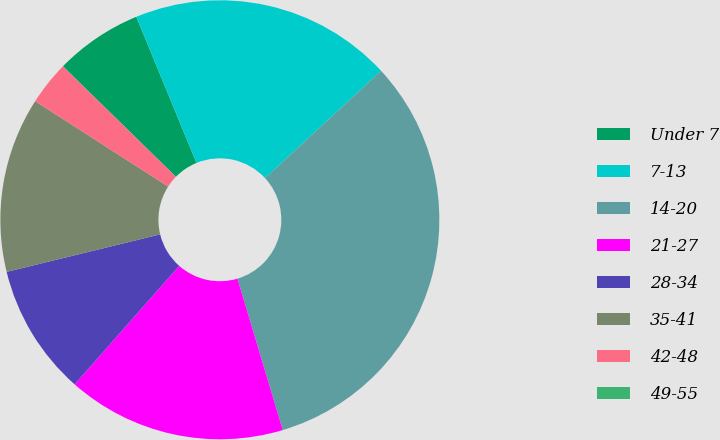Convert chart to OTSL. <chart><loc_0><loc_0><loc_500><loc_500><pie_chart><fcel>Under 7<fcel>7-13<fcel>14-20<fcel>21-27<fcel>28-34<fcel>35-41<fcel>42-48<fcel>49-55<nl><fcel>6.46%<fcel>19.35%<fcel>32.24%<fcel>16.13%<fcel>9.68%<fcel>12.9%<fcel>3.23%<fcel>0.01%<nl></chart> 